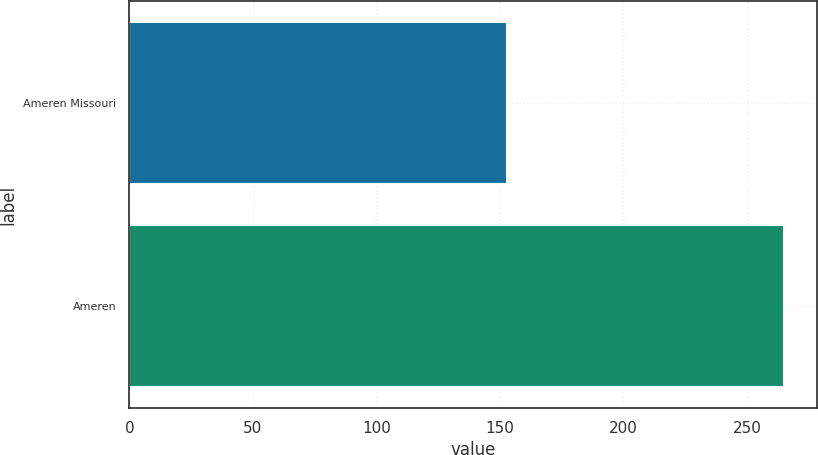<chart> <loc_0><loc_0><loc_500><loc_500><bar_chart><fcel>Ameren Missouri<fcel>Ameren<nl><fcel>153<fcel>265<nl></chart> 